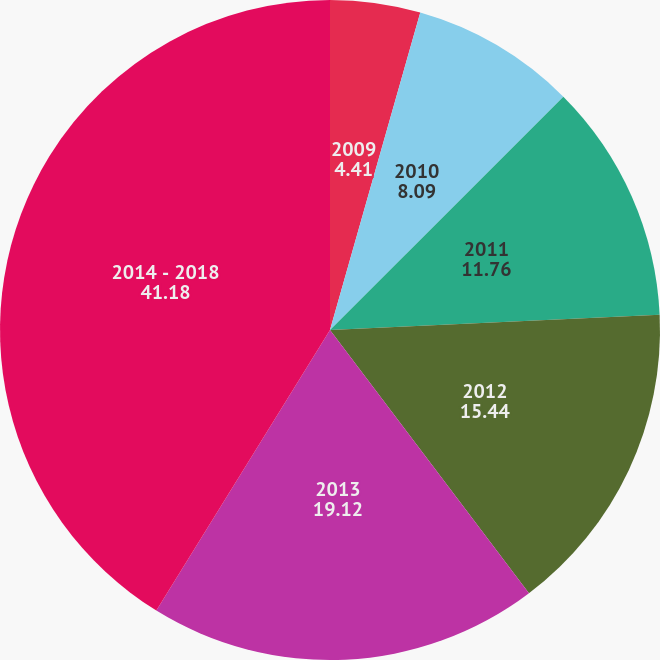<chart> <loc_0><loc_0><loc_500><loc_500><pie_chart><fcel>2009<fcel>2010<fcel>2011<fcel>2012<fcel>2013<fcel>2014 - 2018<nl><fcel>4.41%<fcel>8.09%<fcel>11.76%<fcel>15.44%<fcel>19.12%<fcel>41.18%<nl></chart> 